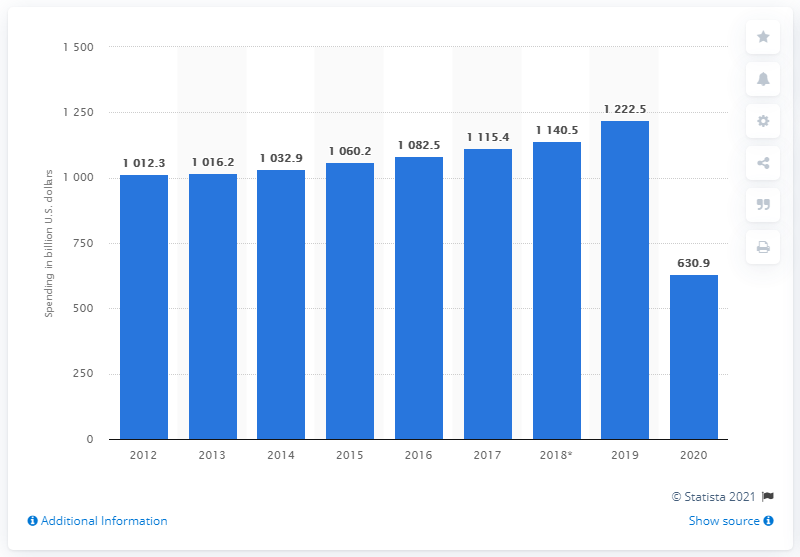Specify some key components in this picture. In 2020, domestic travelers in Europe spent a total of 630.9 billion U.S. dollars on travel and tourism. 